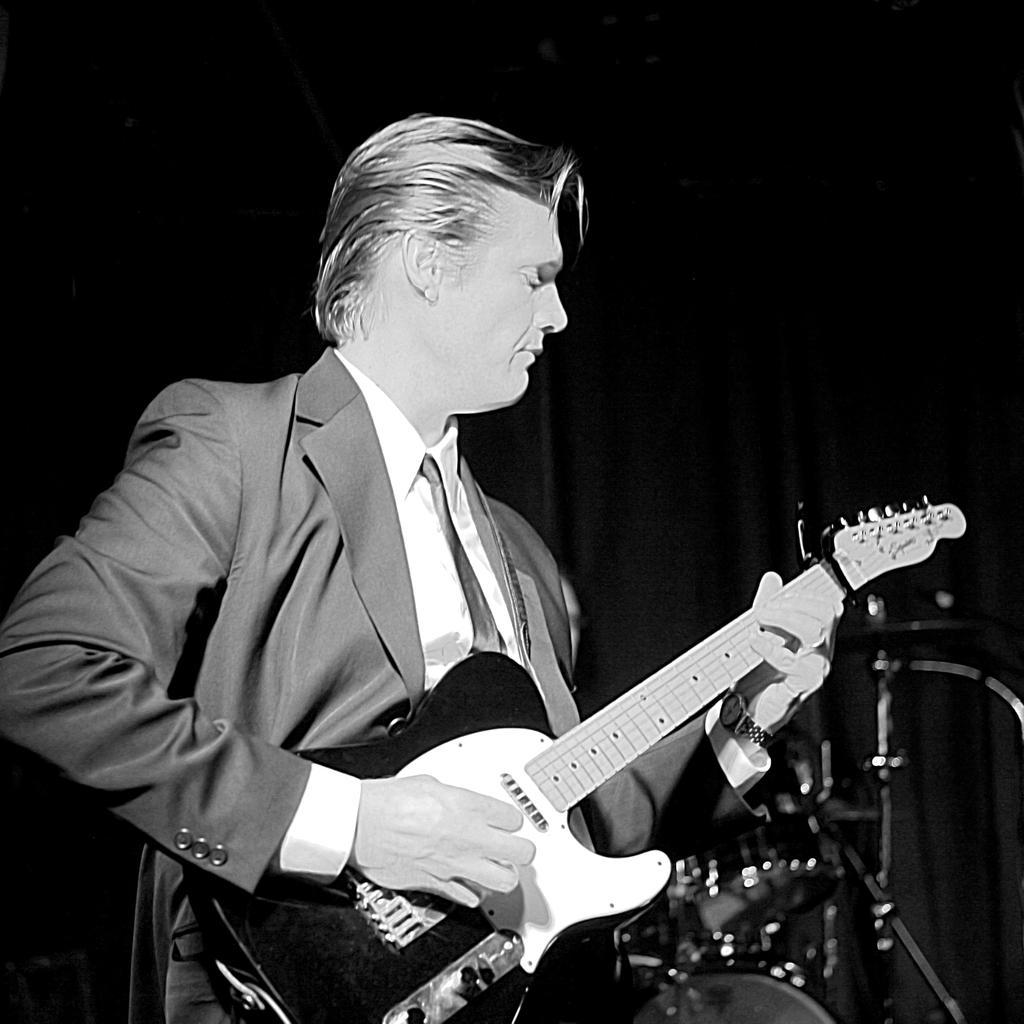Could you give a brief overview of what you see in this image? In this image I can see a man is holding a guitar. 